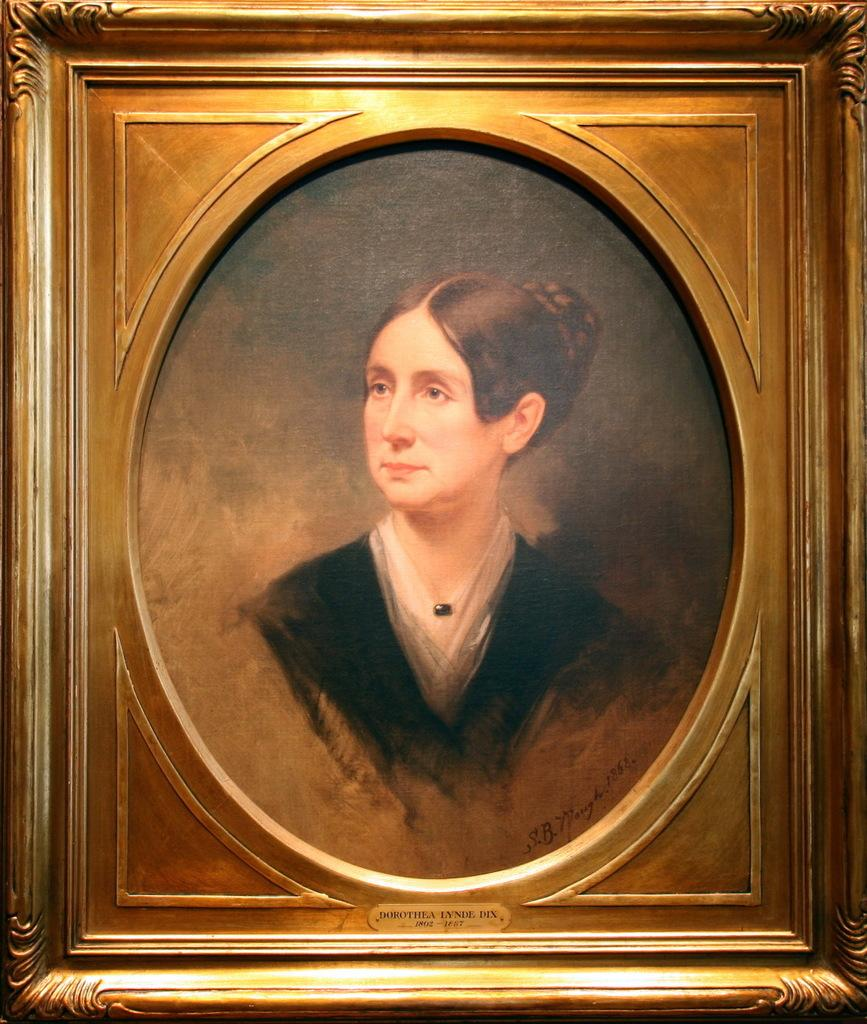What object is present in the image that holds a visual representation? There is a photo frame in the image. What is displayed within the photo frame? The photo frame contains a painting. What subject matter is depicted in the painting? The painting depicts a woman. What type of cannon is shown in the painting within the photo frame? There is no cannon present in the image, as the painting depicts a woman and not a cannon. 